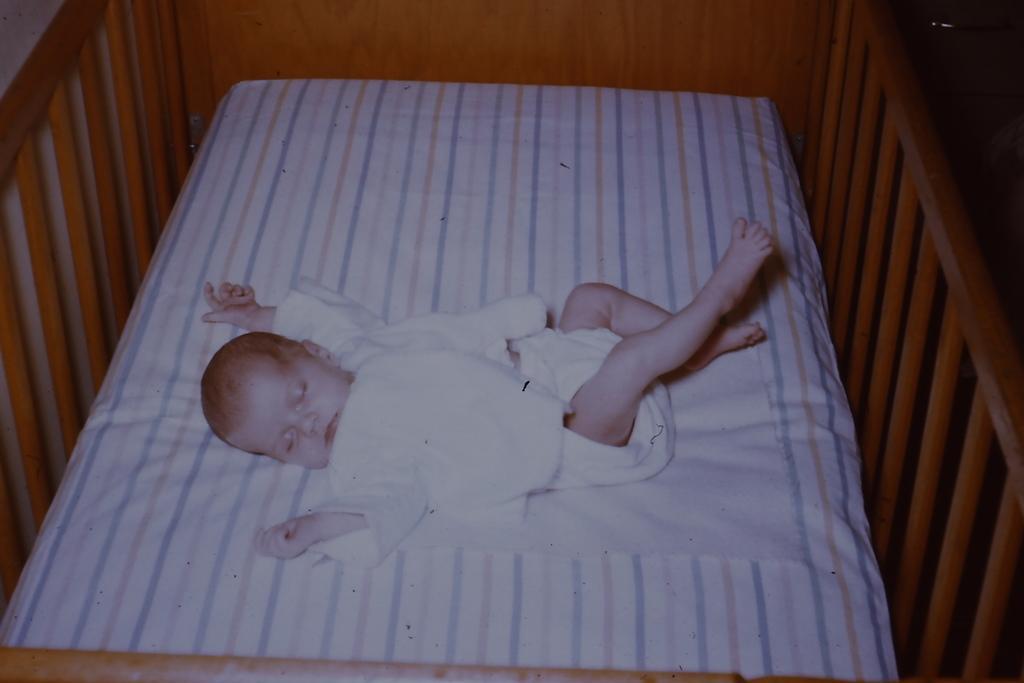In one or two sentences, can you explain what this image depicts? In this picture, we can see a child lying in a cradle. 